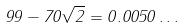<formula> <loc_0><loc_0><loc_500><loc_500>9 9 - 7 0 \sqrt { 2 } = 0 . 0 0 5 0 \dots</formula> 